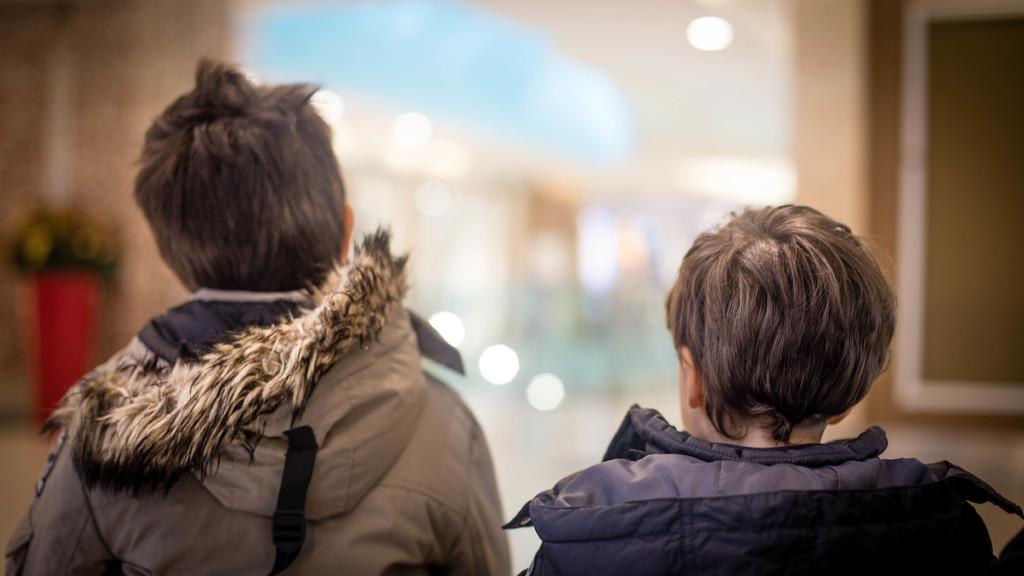Who is present in the image? There are kids in the image. What can be seen at the top of the image? There are lights visible at the top of the image. What type of shop can be seen in the image? There is no shop present in the image; it only features kids and lights. How many answers can be found in the image? The image does not contain any questions or answers, so it is not possible to determine the number of answers present. 